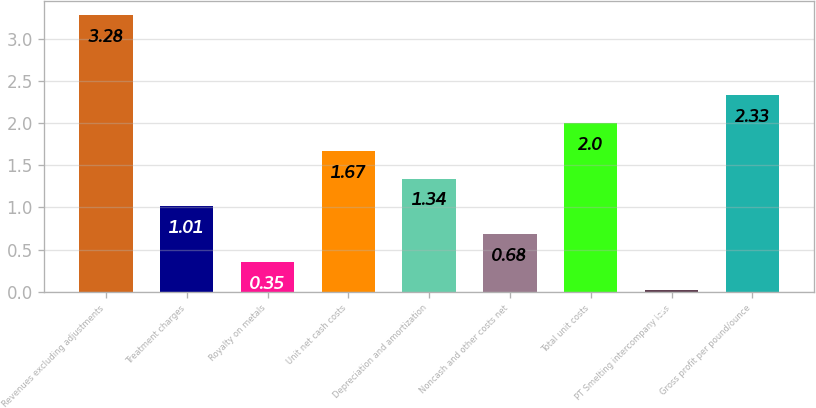Convert chart. <chart><loc_0><loc_0><loc_500><loc_500><bar_chart><fcel>Revenues excluding adjustments<fcel>Treatment charges<fcel>Royalty on metals<fcel>Unit net cash costs<fcel>Depreciation and amortization<fcel>Noncash and other costs net<fcel>Total unit costs<fcel>PT Smelting intercompany loss<fcel>Gross profit per pound/ounce<nl><fcel>3.28<fcel>1.01<fcel>0.35<fcel>1.67<fcel>1.34<fcel>0.68<fcel>2<fcel>0.02<fcel>2.33<nl></chart> 